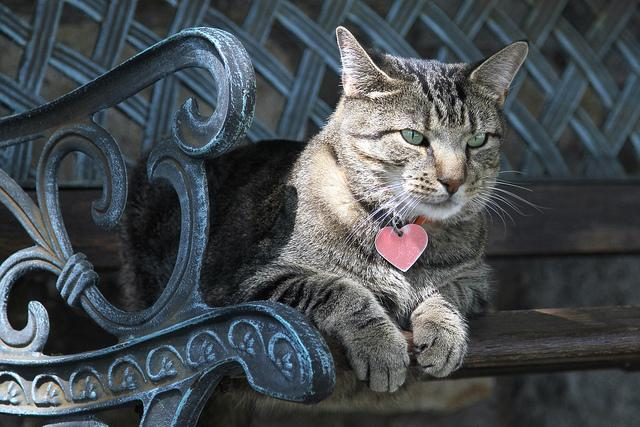What is the purpose of the heart around the cats neck? Please explain your reasoning. identification. The cat is wearing a tag on its neck with owner information on it. 